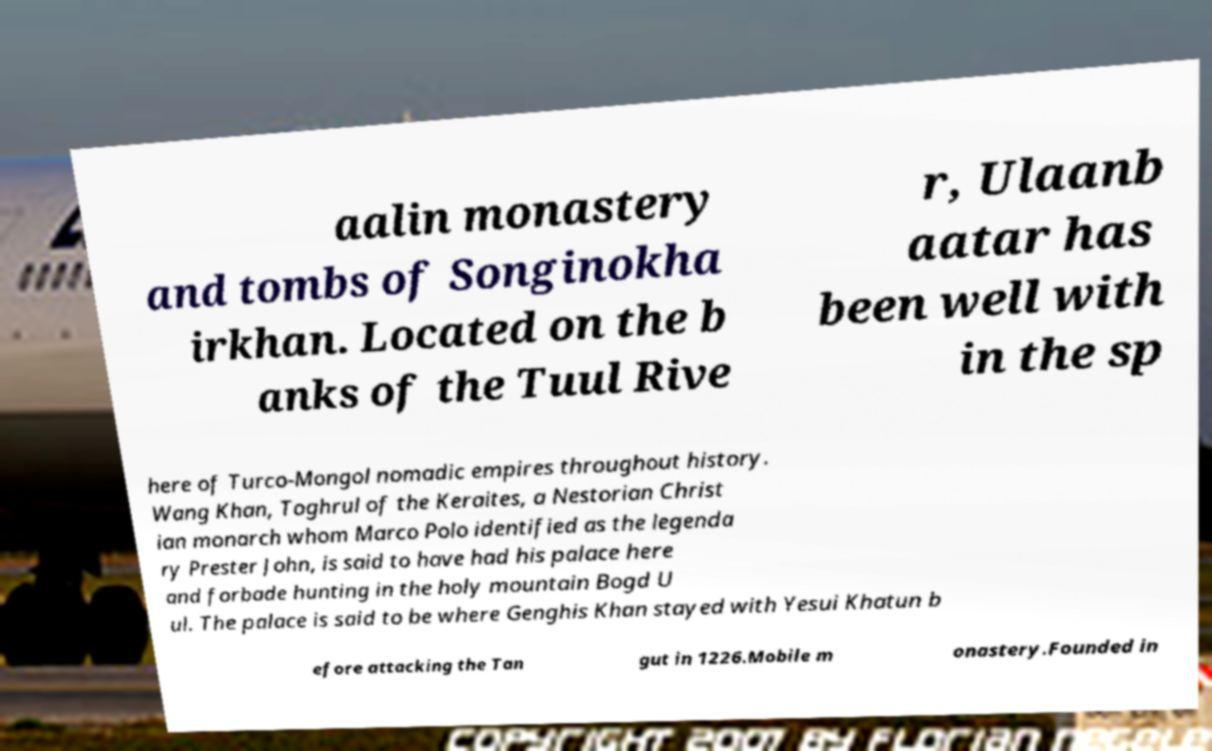I need the written content from this picture converted into text. Can you do that? aalin monastery and tombs of Songinokha irkhan. Located on the b anks of the Tuul Rive r, Ulaanb aatar has been well with in the sp here of Turco-Mongol nomadic empires throughout history. Wang Khan, Toghrul of the Keraites, a Nestorian Christ ian monarch whom Marco Polo identified as the legenda ry Prester John, is said to have had his palace here and forbade hunting in the holy mountain Bogd U ul. The palace is said to be where Genghis Khan stayed with Yesui Khatun b efore attacking the Tan gut in 1226.Mobile m onastery.Founded in 